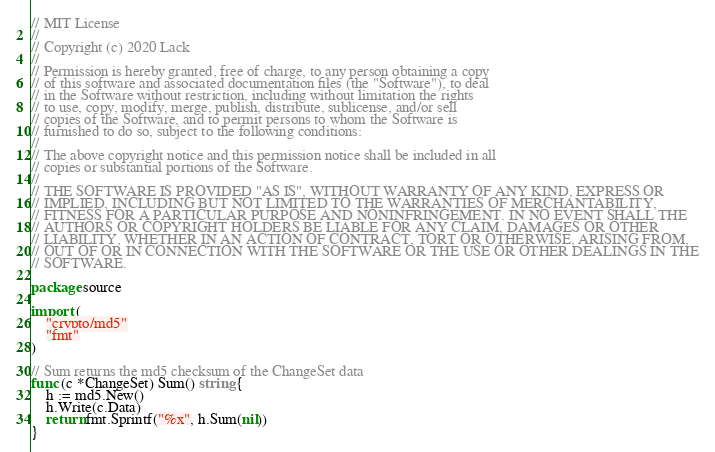Convert code to text. <code><loc_0><loc_0><loc_500><loc_500><_Go_>// MIT License
//
// Copyright (c) 2020 Lack
//
// Permission is hereby granted, free of charge, to any person obtaining a copy
// of this software and associated documentation files (the "Software"), to deal
// in the Software without restriction, including without limitation the rights
// to use, copy, modify, merge, publish, distribute, sublicense, and/or sell
// copies of the Software, and to permit persons to whom the Software is
// furnished to do so, subject to the following conditions:
//
// The above copyright notice and this permission notice shall be included in all
// copies or substantial portions of the Software.
//
// THE SOFTWARE IS PROVIDED "AS IS", WITHOUT WARRANTY OF ANY KIND, EXPRESS OR
// IMPLIED, INCLUDING BUT NOT LIMITED TO THE WARRANTIES OF MERCHANTABILITY,
// FITNESS FOR A PARTICULAR PURPOSE AND NONINFRINGEMENT. IN NO EVENT SHALL THE
// AUTHORS OR COPYRIGHT HOLDERS BE LIABLE FOR ANY CLAIM, DAMAGES OR OTHER
// LIABILITY, WHETHER IN AN ACTION OF CONTRACT, TORT OR OTHERWISE, ARISING FROM,
// OUT OF OR IN CONNECTION WITH THE SOFTWARE OR THE USE OR OTHER DEALINGS IN THE
// SOFTWARE.

package source

import (
	"crypto/md5"
	"fmt"
)

// Sum returns the md5 checksum of the ChangeSet data
func (c *ChangeSet) Sum() string {
	h := md5.New()
	h.Write(c.Data)
	return fmt.Sprintf("%x", h.Sum(nil))
}
</code> 